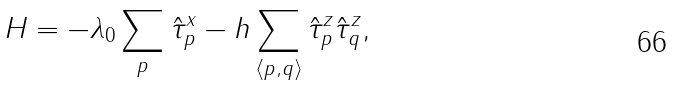<formula> <loc_0><loc_0><loc_500><loc_500>H = - \lambda _ { 0 } \sum _ { p } \hat { \tau } ^ { x } _ { p } - h \sum _ { \langle p , q \rangle } \hat { \tau } ^ { z } _ { p } \hat { \tau } ^ { z } _ { q } ,</formula> 